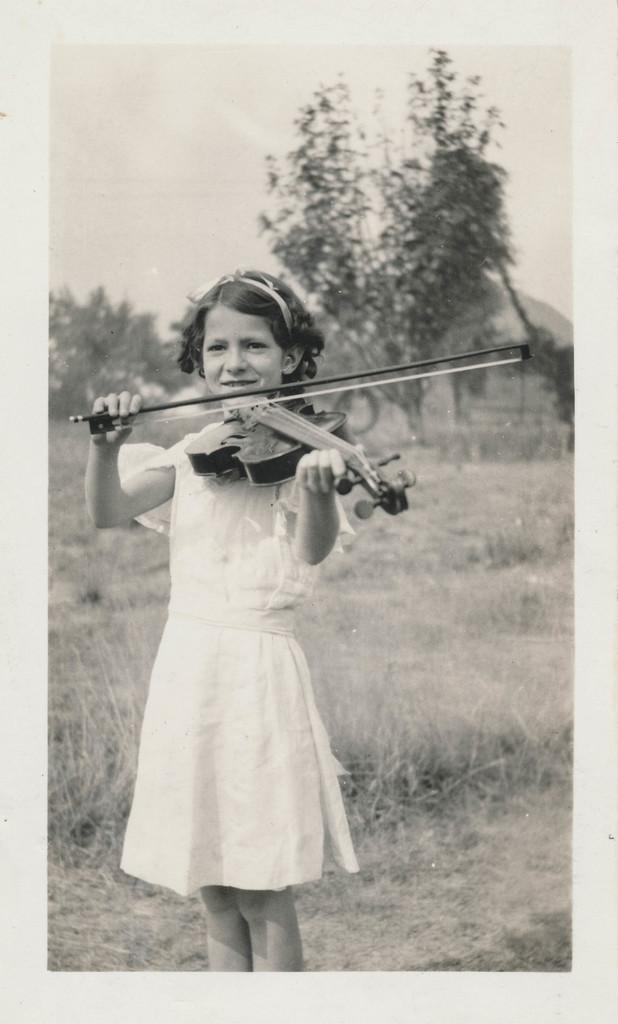What is the color scheme of the image? The image is black and white. What is the girl in the image doing? The girl is playing the violin in the image. What can be seen in the background of the image? There are trees in the background of the image. What type of vegetation is present at the bottom of the image? The ground is covered with grass at the bottom of the image. How many ants can be seen carrying quince on a boat in the image? There are no ants, quince, or boats present in the image. 